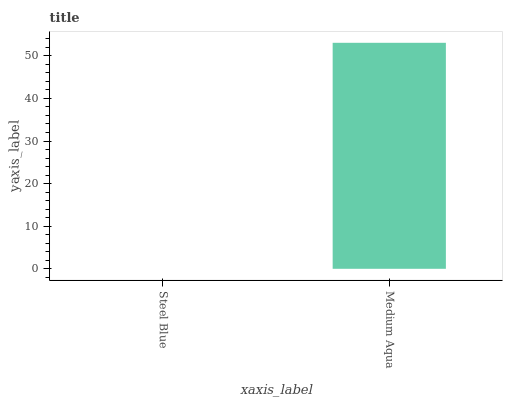Is Steel Blue the minimum?
Answer yes or no. Yes. Is Medium Aqua the maximum?
Answer yes or no. Yes. Is Medium Aqua the minimum?
Answer yes or no. No. Is Medium Aqua greater than Steel Blue?
Answer yes or no. Yes. Is Steel Blue less than Medium Aqua?
Answer yes or no. Yes. Is Steel Blue greater than Medium Aqua?
Answer yes or no. No. Is Medium Aqua less than Steel Blue?
Answer yes or no. No. Is Medium Aqua the high median?
Answer yes or no. Yes. Is Steel Blue the low median?
Answer yes or no. Yes. Is Steel Blue the high median?
Answer yes or no. No. Is Medium Aqua the low median?
Answer yes or no. No. 